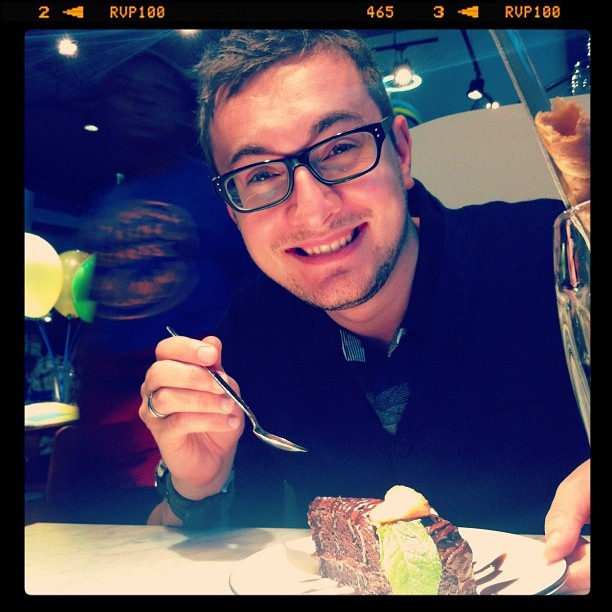Describe the objects in this image and their specific colors. I can see people in black, navy, salmon, and brown tones, dining table in black, beige, khaki, tan, and darkgray tones, cake in black, khaki, tan, gray, and beige tones, cup in black, navy, gray, and darkgray tones, and spoon in black, navy, ivory, gray, and darkgray tones in this image. 